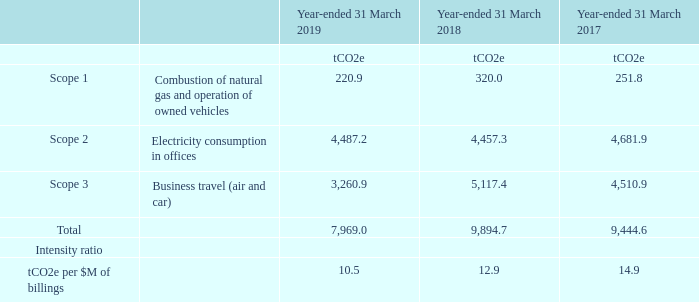Greenhouse gas emissions
In line with the Companies Act 2006, Sophos is required to measure and report on its Greenhouse Gas (“GHG”) emissions disclosures. These have been calculated for the year-ending 31 March 2019, in line with the Group’s financial year. The calculation of the disclosures has been performed in accordance with Greenhouse Gas Protocol Corporate Standard and using the UK government’s conversion factor guidance for the year reported.
The Group’s operations that primarily release GHG includes usage of electricity and gas of owned and leased offices, business travel and usage of vehicles. The Group keeps its data capture process under review, seeking to extend the availability of direct information wherever possible. Where direct information for certain sites is not available, estimates have been developed that enable reporting for them. These estimates are revised if new or improved data is obtained.
The Group will continue to build its GHG reporting capabilities. The Group’s chosen intensity ratio is ‘tonnes of CO2 equivalent per million US dollars of billings’ as it aligns with Sophos’ strategic growth ambitions.
Creating an environmentally friendly HQ
The Group commissioned a greening study of its global headquarters in Abingdon, Oxfordshire. The purpose of the study was to benchmark the current environmental, health and wellbeing performance of the building against current best practice and against direct and indirect competitors.
The findings of the study showed that the building performance was consistent with intermediate good practice and the building management was consistent with standard good practice. The study highlighted areas of future improvement. The findings and recommendations of this report will be a key driver for developing best practice in environmental sustainability to match the growth aspirations and objectives of the Company.
The Group is endeavouring to achieve the standards in environmental performance, health and wellbeing that is expected of a global technology organisation at the Group’s headquarters.
What does the Companies Act 2006 require Sophos to do? Sophos is required to measure and report on its greenhouse gas (“ghg”) emissions disclosures. What does the Group's operations that primarily release GHG include? Usage of electricity and gas of owned and leased offices, business travel and usage of vehicles. What are the scopes considered in the table when calculating the total greenhouse gas emissions? Combustion of natural gas and operation of owned vehicles, electricity consumption in offices, business travel (air and car). In which year was the total Greenhouse gas emissions the largest? 9,894.7>9,444.6>7,969.0
Answer: 2018. What was the change in the intensity ratio in 2019 from 2018? 10.5-12.9
Answer: -2.4. What was the percentage change in the intensity ratio in 2019 from 2018?
Answer scale should be: percent. (10.5-12.9)/12.9
Answer: -18.6. 